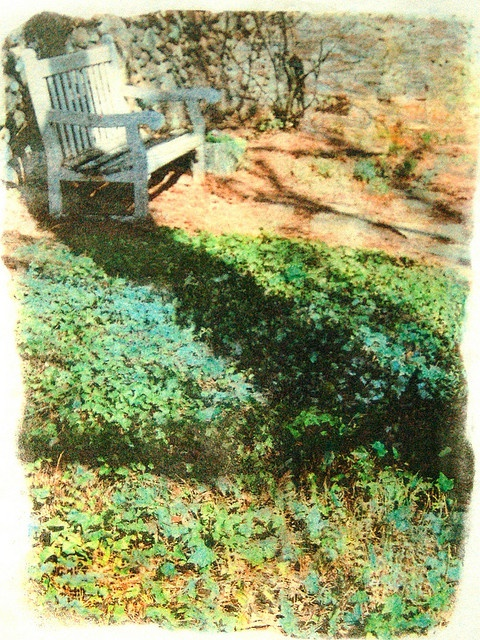Describe the objects in this image and their specific colors. I can see a bench in white, darkgray, beige, and gray tones in this image. 